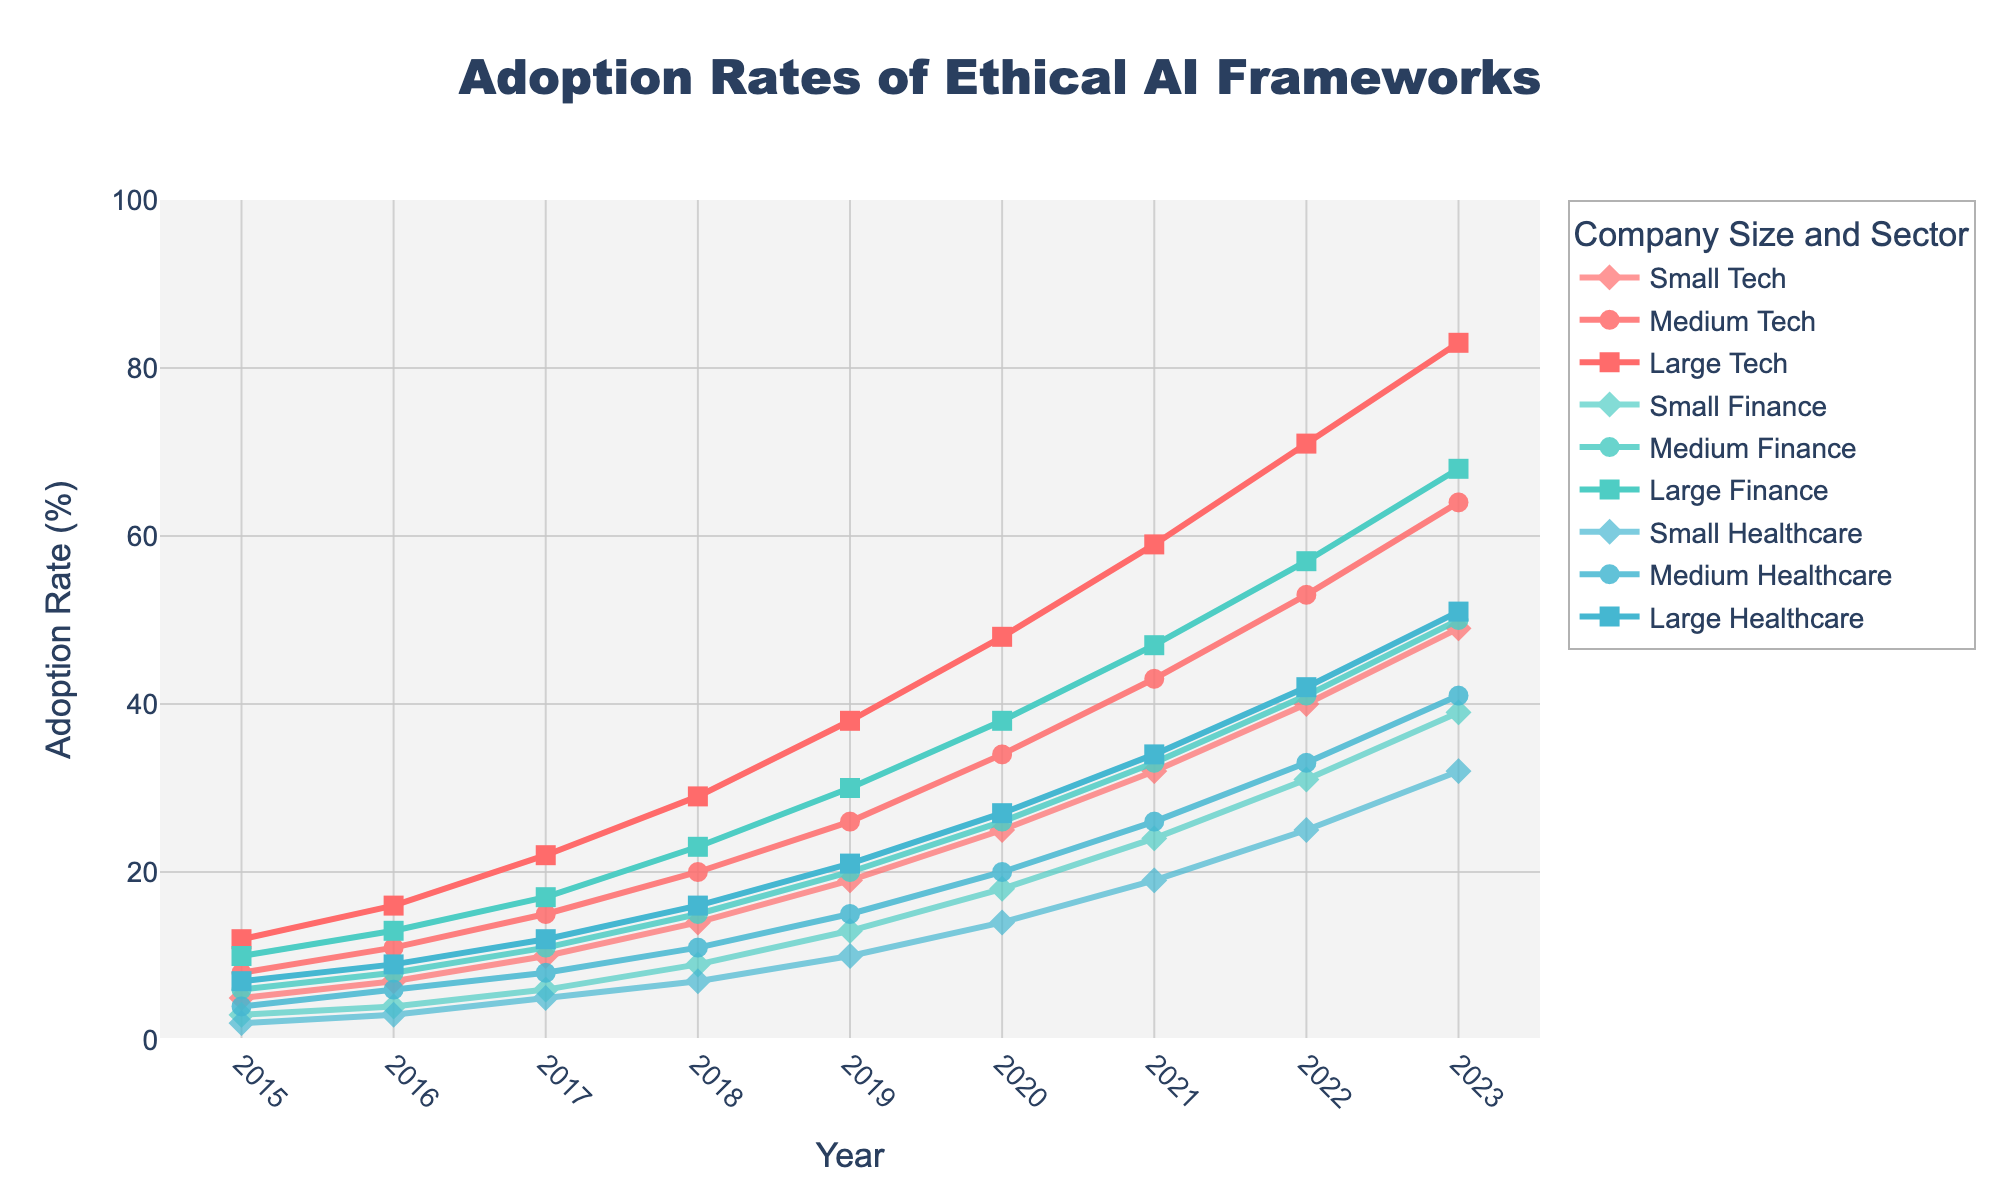What is the adoption rate of ethical AI frameworks in Large Tech companies in 2023? Look at the figure and locate the "Large Tech" line at the year 2023 on the x-axis. Check where it intersects with the y-axis.
Answer: 83% Which sector had the highest adoption rate of ethical AI frameworks in Small companies in 2017? Find the year 2017 on the x-axis, then locate the points for "Small Tech," "Small Finance," and "Small Healthcare." Compare their y-axis values to determine the highest.
Answer: Small Tech What is the difference in the adoption rate between Medium Tech and Large Healthcare in 2020? Locate the year 2020 on the x-axis. Find the y-axis values for "Medium Tech" and "Large Healthcare" and then calculate the difference. Medium Tech is at 34%, and Large Healthcare is at 27%. 34 - 27 = 7.
Answer: 7% Between 2015 and 2023, which sector and company size showed the highest overall increase in adoption rates? Calculate the increase for each sector and company size from 2015 to 2023 and compare them. Large Tech had the highest increase from 12% in 2015 to 83% in 2023. 83 - 12 = 71.
Answer: Large Tech In 2019, were there more companies in the Tech sector or Finance sector adopting ethical AI frameworks for Medium company sizes? Find the adoption rates for "Medium Tech" and "Medium Finance" in 2019 on the figure. Medium Tech has 26% and Medium Finance has 20%. Compare these two values.
Answer: Tech sector What is the average adoption rate of ethical AI frameworks for Small companies across all sectors in 2019? Look at the 2019 adoption rates for "Small Tech," "Small Finance," and "Small Healthcare," which are 19%, 13%, and 10%, respectively. Calculate the average: (19 + 13 + 10) / 3 = 14.
Answer: 14% How does the adoption rate of Medium Healthcare in 2021 compare to Medium Finance in the same year? Check the adoption rates for "Medium Healthcare" and "Medium Finance" in 2021. Medium Healthcare is at 26% and Medium Finance is at 33%.
Answer: Medium Healthcare is 7% less Which company size in the Tech sector saw the fastest growth in adoption rates between 2018 and 2020? Calculate the growth for Small, Medium, and Large Tech between 2018 and 2020. Small Tech grew from 14% to 25%, an 11% increase. Medium Tech grew from 20% to 34%, a 14% increase. Large Tech grew from 29% to 48%, a 19% increase.
Answer: Large Tech In 2023, what is the visual pattern used to denote the adoption rate of ethical AI frameworks in Small companies across all sectors? Observe the markers representing "Small" companies in each sector in 2023. They are marked by diamonds.
Answer: Diamonds 